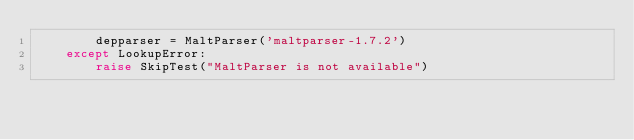<code> <loc_0><loc_0><loc_500><loc_500><_Python_>        depparser = MaltParser('maltparser-1.7.2')
    except LookupError:
        raise SkipTest("MaltParser is not available")
</code> 